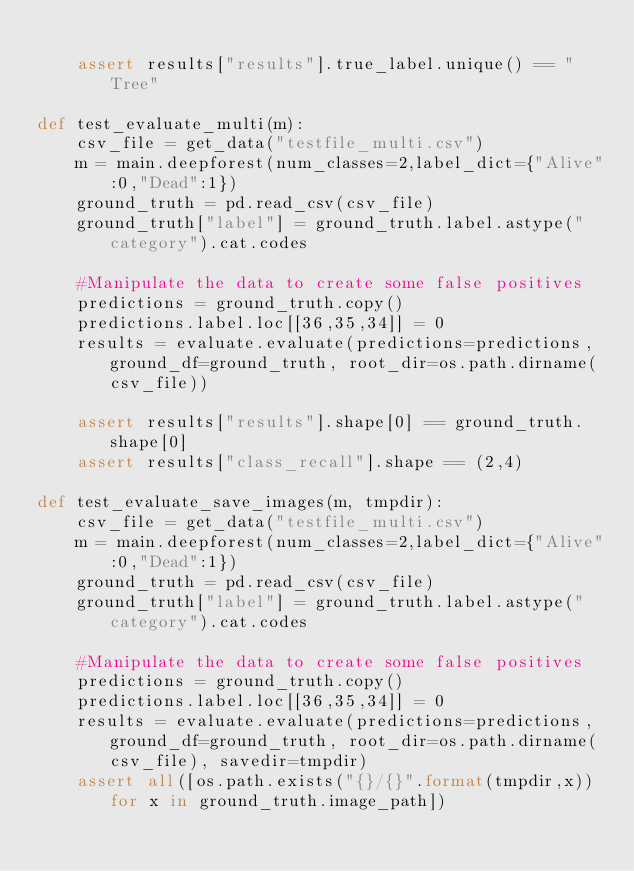<code> <loc_0><loc_0><loc_500><loc_500><_Python_>    
    assert results["results"].true_label.unique() == "Tree"

def test_evaluate_multi(m):
    csv_file = get_data("testfile_multi.csv")
    m = main.deepforest(num_classes=2,label_dict={"Alive":0,"Dead":1})
    ground_truth = pd.read_csv(csv_file)
    ground_truth["label"] = ground_truth.label.astype("category").cat.codes
    
    #Manipulate the data to create some false positives
    predictions = ground_truth.copy()
    predictions.label.loc[[36,35,34]] = 0
    results = evaluate.evaluate(predictions=predictions, ground_df=ground_truth, root_dir=os.path.dirname(csv_file))     
        
    assert results["results"].shape[0] == ground_truth.shape[0]
    assert results["class_recall"].shape == (2,4)
    
def test_evaluate_save_images(m, tmpdir):
    csv_file = get_data("testfile_multi.csv")
    m = main.deepforest(num_classes=2,label_dict={"Alive":0,"Dead":1})
    ground_truth = pd.read_csv(csv_file)
    ground_truth["label"] = ground_truth.label.astype("category").cat.codes
    
    #Manipulate the data to create some false positives
    predictions = ground_truth.copy()
    predictions.label.loc[[36,35,34]] = 0
    results = evaluate.evaluate(predictions=predictions, ground_df=ground_truth, root_dir=os.path.dirname(csv_file), savedir=tmpdir)     
    assert all([os.path.exists("{}/{}".format(tmpdir,x)) for x in ground_truth.image_path])</code> 